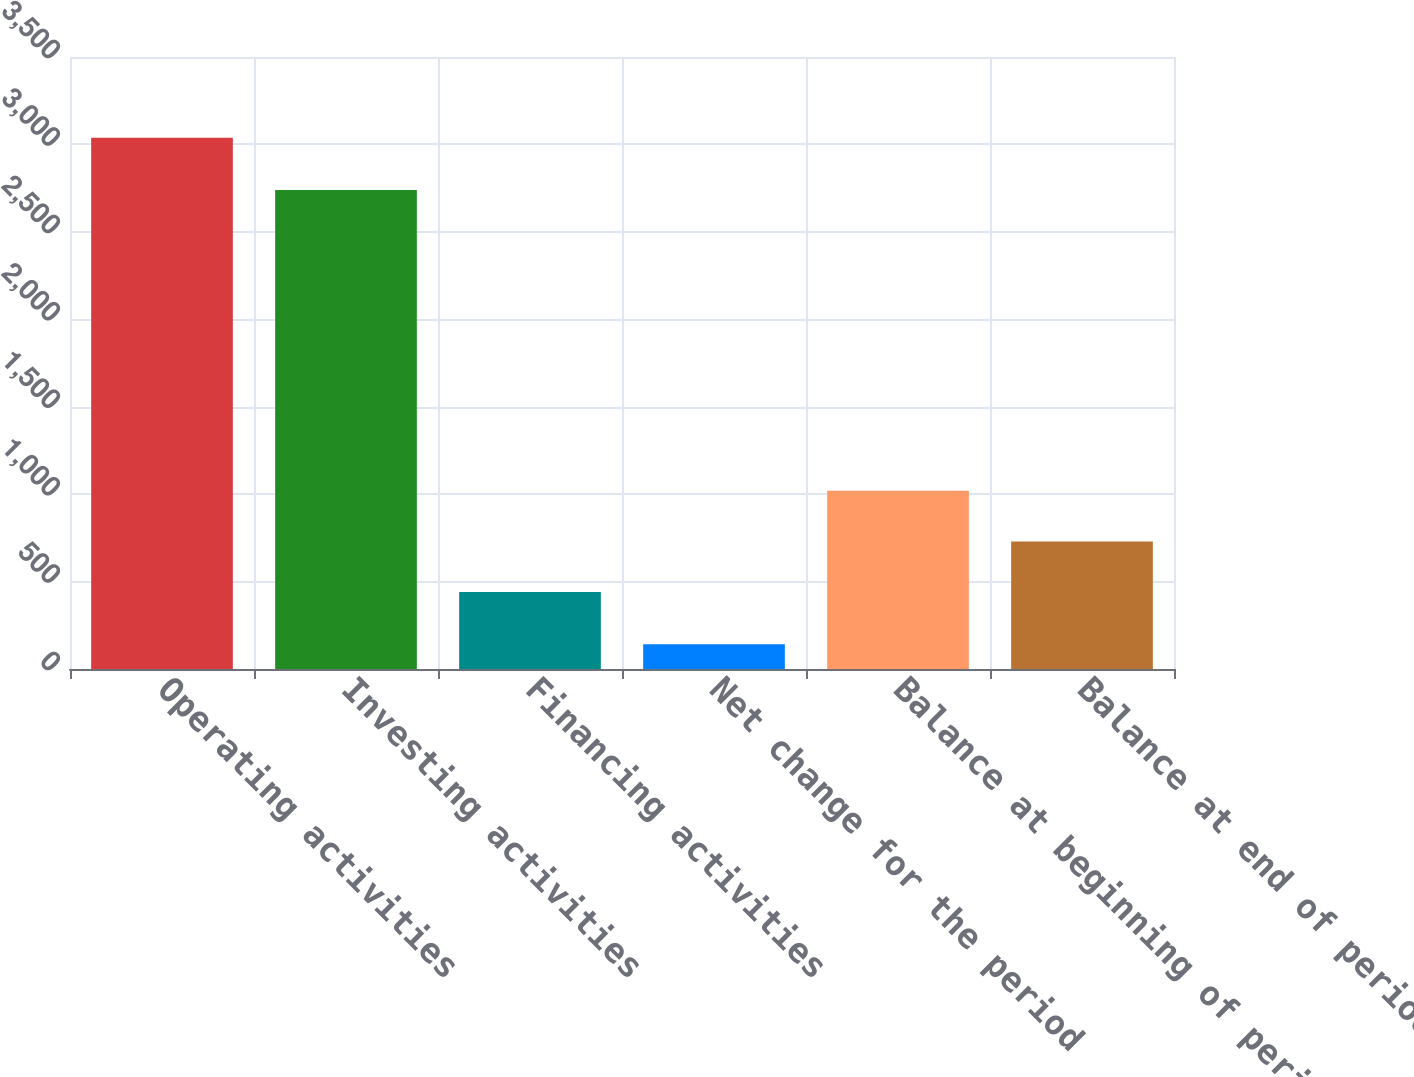Convert chart to OTSL. <chart><loc_0><loc_0><loc_500><loc_500><bar_chart><fcel>Operating activities<fcel>Investing activities<fcel>Financing activities<fcel>Net change for the period<fcel>Balance at beginning of period<fcel>Balance at end of period<nl><fcel>3038<fcel>2739<fcel>440<fcel>141<fcel>1019.4<fcel>729.7<nl></chart> 